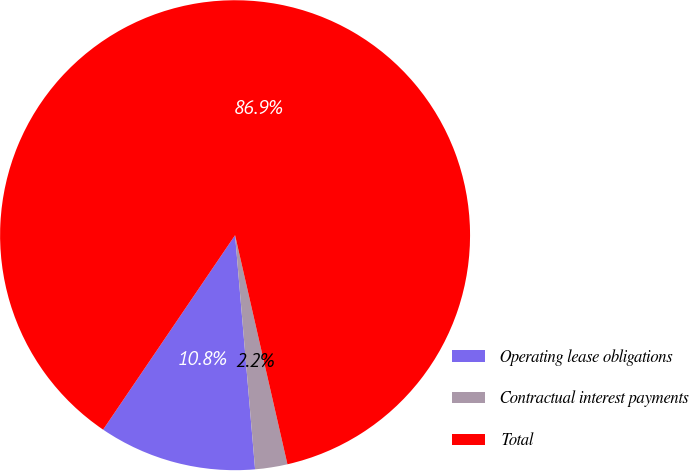<chart> <loc_0><loc_0><loc_500><loc_500><pie_chart><fcel>Operating lease obligations<fcel>Contractual interest payments<fcel>Total<nl><fcel>10.85%<fcel>2.22%<fcel>86.94%<nl></chart> 